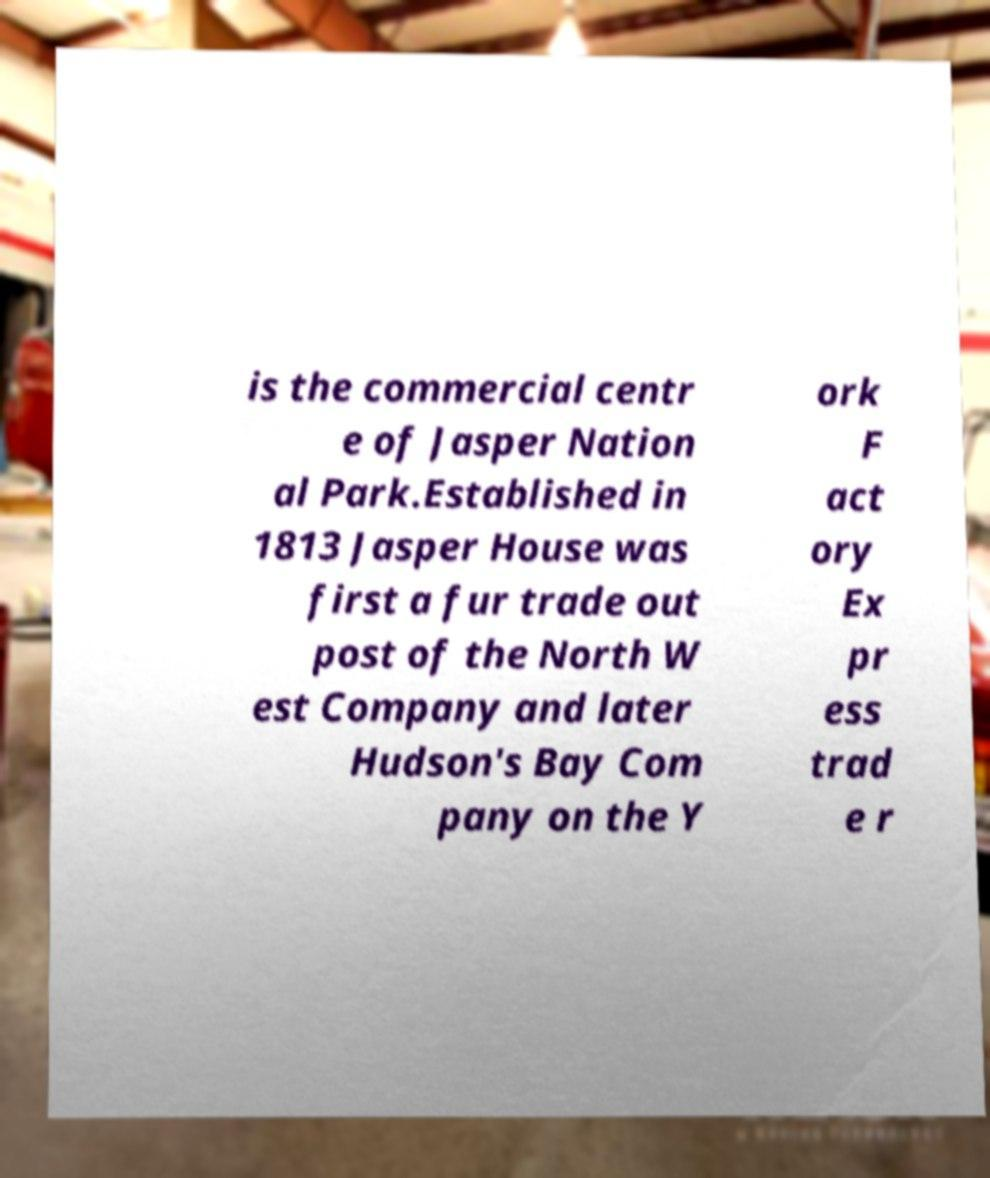Can you accurately transcribe the text from the provided image for me? is the commercial centr e of Jasper Nation al Park.Established in 1813 Jasper House was first a fur trade out post of the North W est Company and later Hudson's Bay Com pany on the Y ork F act ory Ex pr ess trad e r 